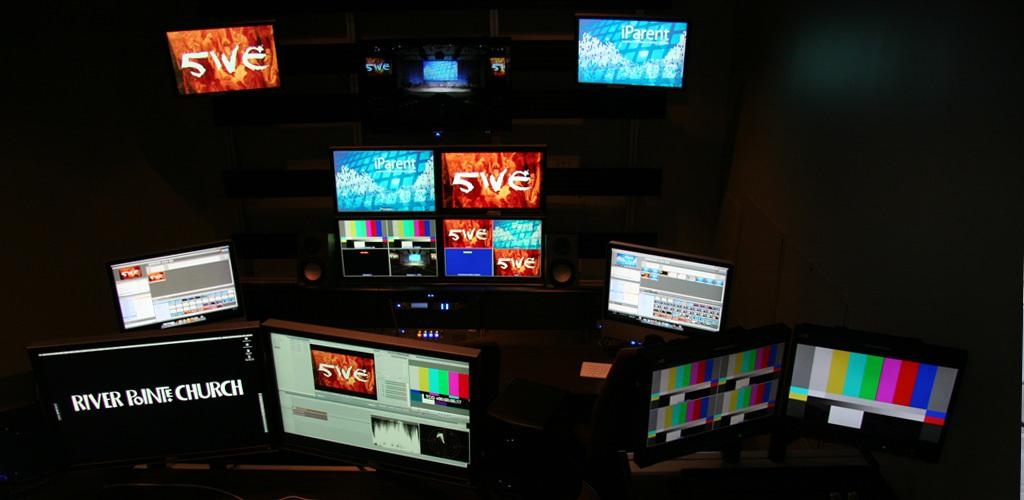<image>
Summarize the visual content of the image. The name River Pointe Church is displayed on a monitor sitting amongst a group of other monitors. 